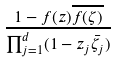<formula> <loc_0><loc_0><loc_500><loc_500>\frac { 1 - f ( z ) \overline { f ( \zeta ) } } { \prod _ { j = 1 } ^ { d } ( 1 - z _ { j } \bar { \zeta _ { j } } ) }</formula> 